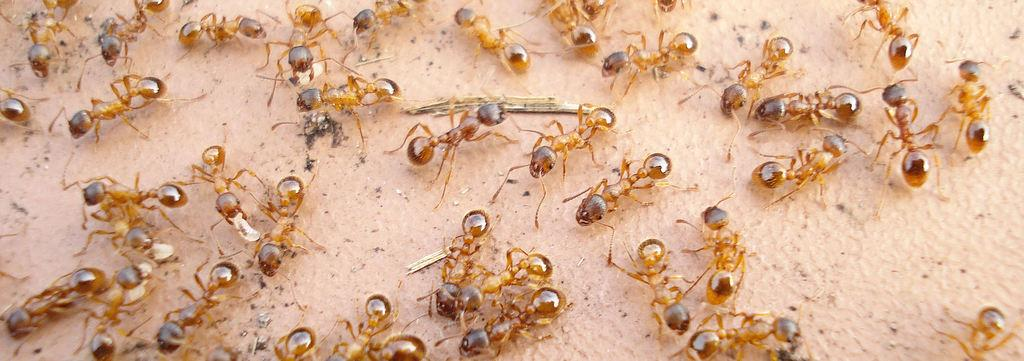What is the main subject of the image? The main subject of the image is a group of ants on the surface of an object. Can you describe the objects visible in the image besides the ants? Unfortunately, the provided facts do not give any information about other objects in the image. What type of power source is being used by the ants in the image? There is no indication in the image that the ants are using any power source. 